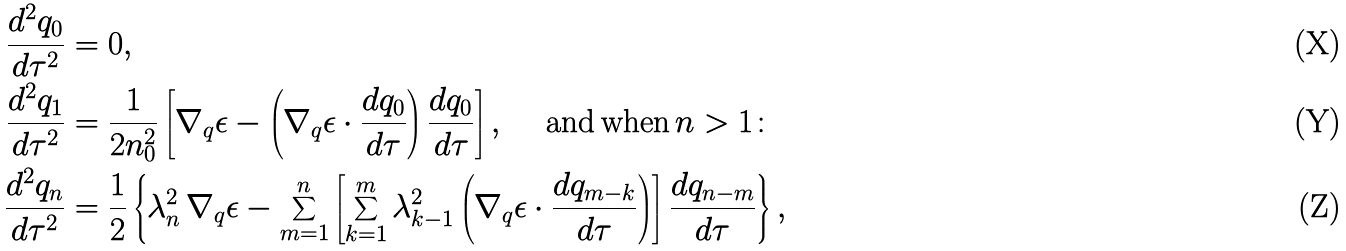<formula> <loc_0><loc_0><loc_500><loc_500>\frac { d ^ { 2 } q _ { 0 } } { d \tau ^ { 2 } } & = 0 , \\ \frac { d ^ { 2 } q _ { 1 } } { d \tau ^ { 2 } } & = \frac { 1 } { 2 n _ { 0 } ^ { 2 } } \left [ \nabla _ { q } \epsilon - \left ( \nabla _ { q } \epsilon \cdot \frac { d q _ { 0 } } { d \tau } \right ) \frac { d q _ { 0 } } { d \tau } \right ] , \quad \text { and\,when\,} n > 1 \colon \\ \frac { d ^ { 2 } q _ { n } } { d \tau ^ { 2 } } & = \frac { 1 } { 2 } \left \{ \lambda ^ { 2 } _ { n } \, \nabla _ { q } \epsilon - \sum ^ { n } _ { m = 1 } \left [ \sum ^ { m } _ { k = 1 } \lambda ^ { 2 } _ { k - 1 } \left ( \nabla _ { q } \epsilon \cdot \frac { d q _ { m - k } } { d \tau } \right ) \right ] \frac { d q _ { n - m } } { d \tau } \right \} ,</formula> 